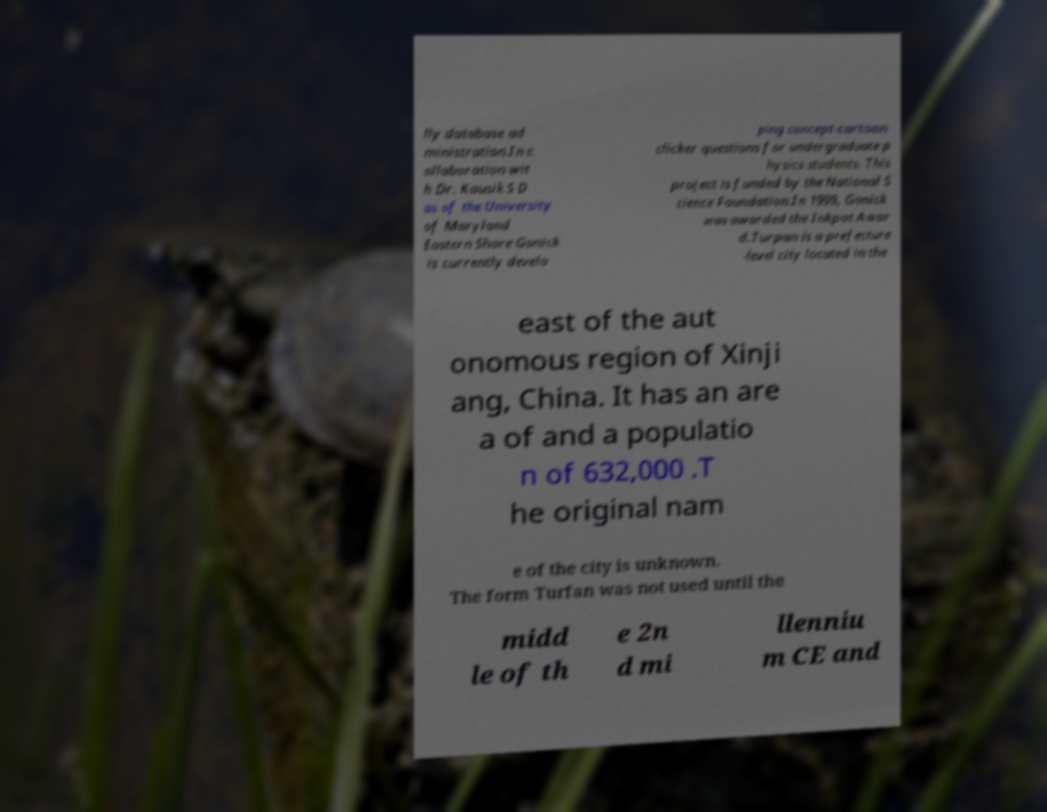Can you accurately transcribe the text from the provided image for me? lly database ad ministration.In c ollaboration wit h Dr. Kausik S D as of the University of Maryland Eastern Shore Gonick is currently develo ping concept-cartoon clicker questions for undergraduate p hysics students. This project is funded by the National S cience Foundation.In 1999, Gonick was awarded the Inkpot Awar d.Turpan is a prefecture -level city located in the east of the aut onomous region of Xinji ang, China. It has an are a of and a populatio n of 632,000 .T he original nam e of the city is unknown. The form Turfan was not used until the midd le of th e 2n d mi llenniu m CE and 